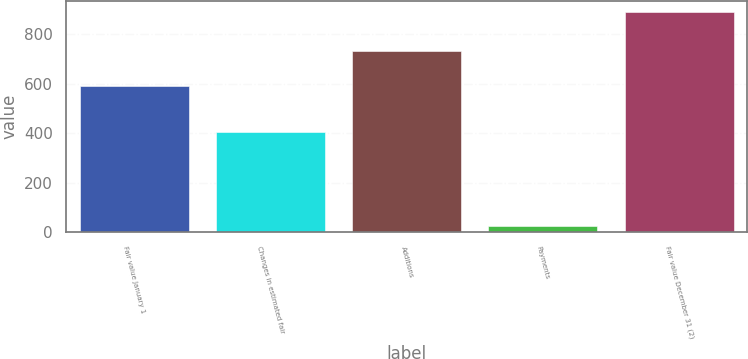Convert chart to OTSL. <chart><loc_0><loc_0><loc_500><loc_500><bar_chart><fcel>Fair value January 1<fcel>Changes in estimated fair<fcel>Additions<fcel>Payments<fcel>Fair value December 31 (2)<nl><fcel>590<fcel>407<fcel>733<fcel>25<fcel>891<nl></chart> 